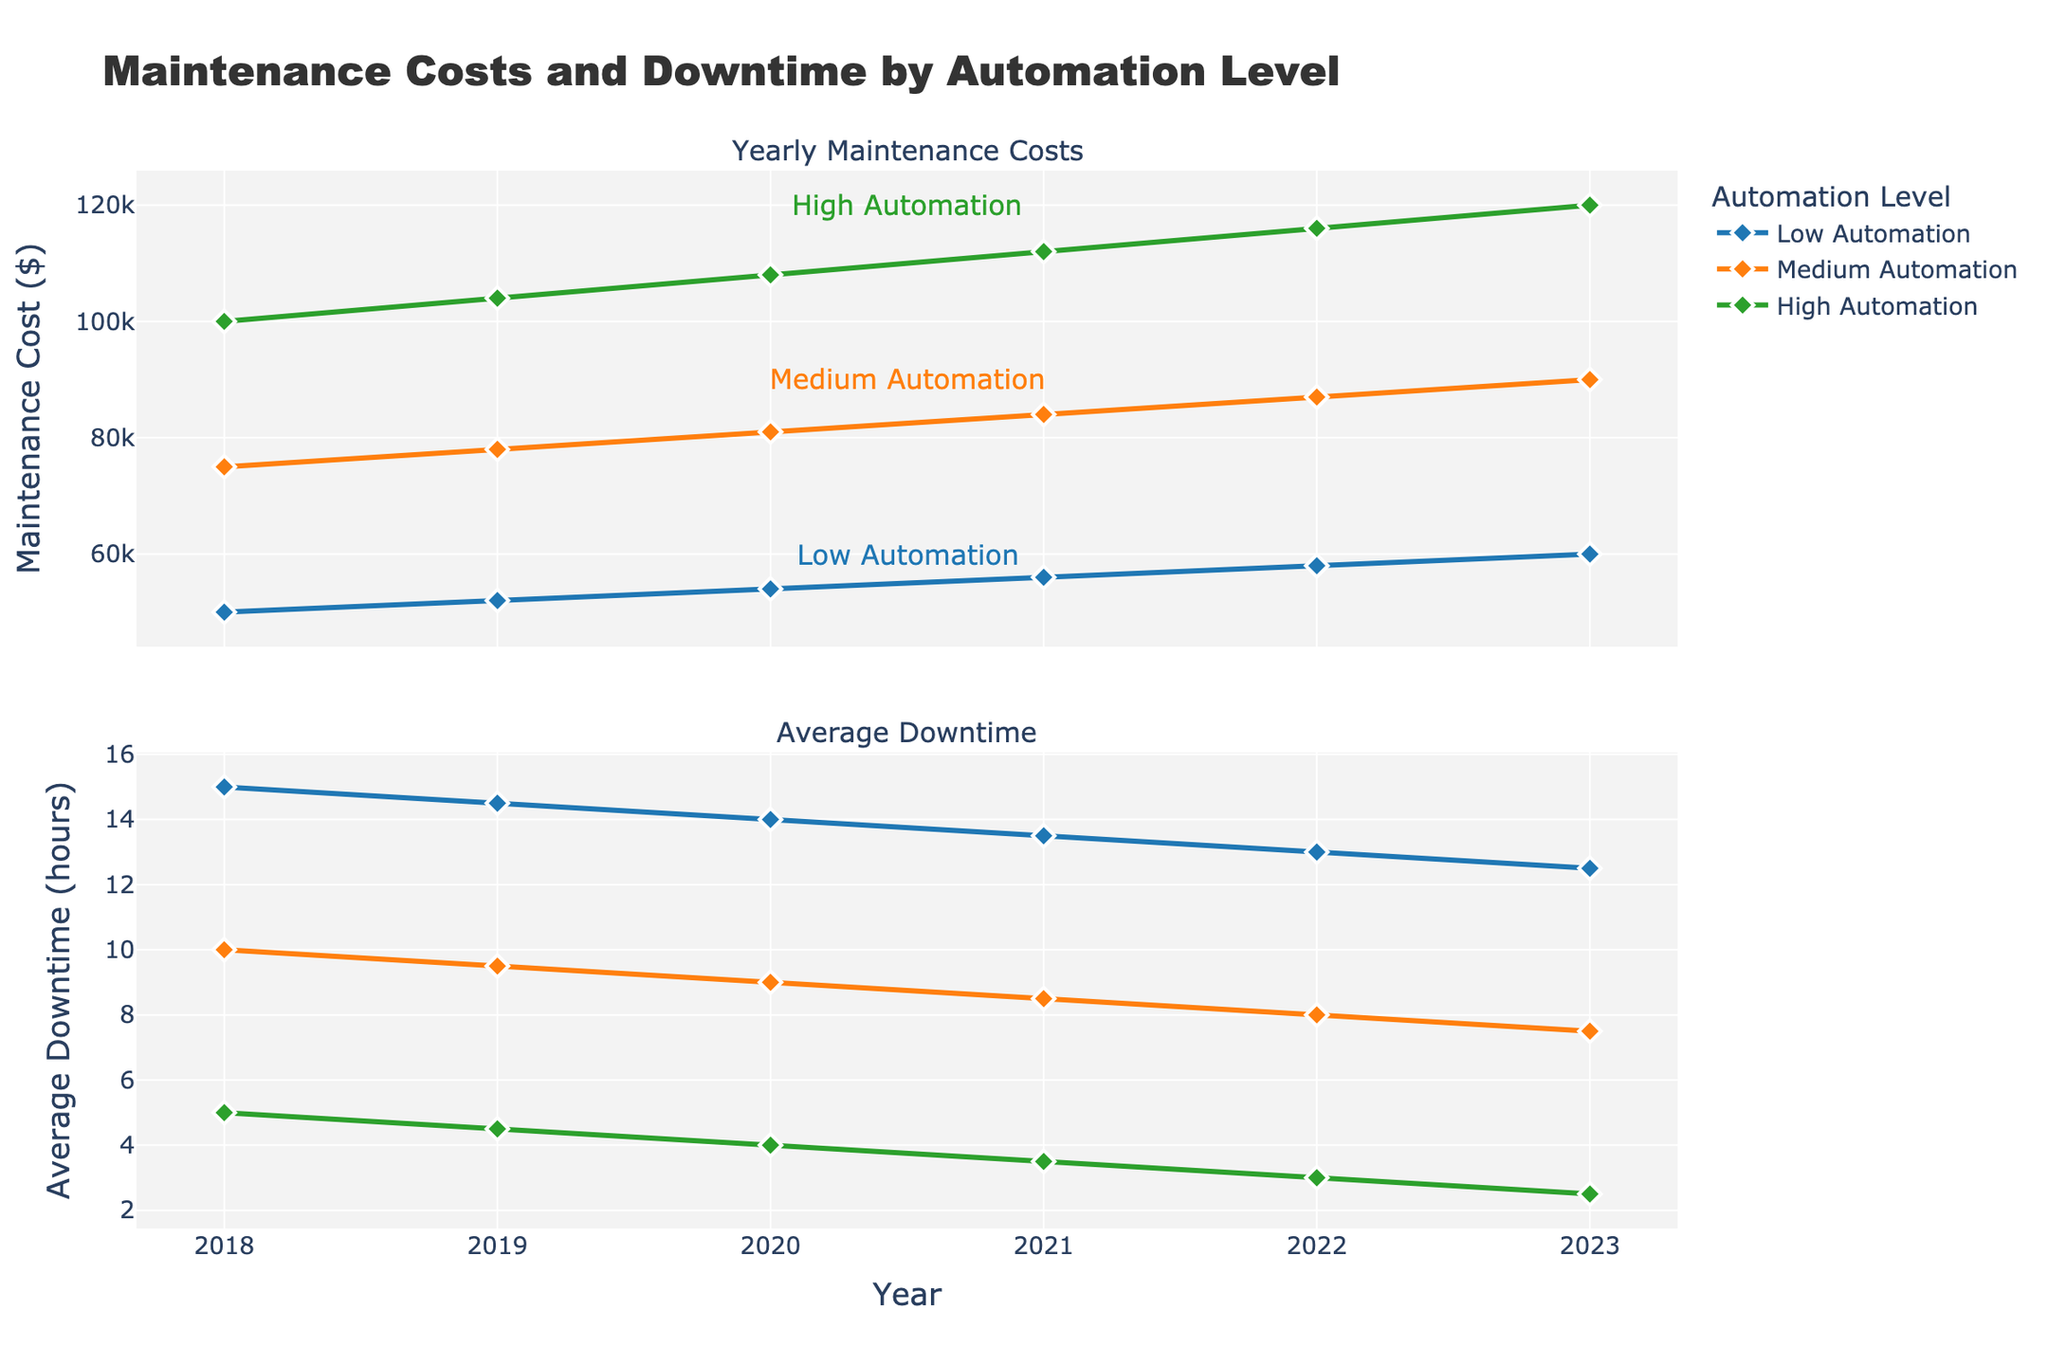What's the title of the figure? The title of the figure is written at the top center of the plot. It reads "Maintenance Costs and Downtime by Automation Level."
Answer: Maintenance Costs and Downtime by Automation Level Which automation level has the highest maintenance cost in 2023? To find the highest maintenance cost in 2023, look at the points for each automation level in the Yearly Maintenance Costs plot for the year 2023. The highest point in 2023 is for High Automation with a value of $120,000.
Answer: High Automation What is the average downtime for Low Automation in 2021? Average Downtime for Low Automation can be found in the Average Downtime plot at the point corresponding to 2021. The value at this point is 13.5 hours.
Answer: 13.5 hours How does average downtime change for Medium Automation from 2018 to 2023? To see how average downtime changes over this period for Medium Automation, follow the line and markers for Medium Automation in the Average Downtime plot from 2018 to 2023. In 2018, the downtime is 10 hours, and it decreases to 7.5 hours in 2023.
Answer: Decreases Compare the maintenance costs of Low and High Automation in 2020. Look at the Yearly Maintenance Costs plot for the year 2020. The maintenance cost for Low Automation is $54,000 and for High Automation is $108,000.
Answer: Low: $54,000, High: $108,000 What trend is observed in the maintenance costs for High Automation from 2018 to 2023? Observe the line for High Automation in the Yearly Maintenance Costs plot from 2018 to 2023. The maintenance costs increase steadily from $100,000 to $120,000 over these years.
Answer: Increasing What is the difference in average downtimes between Low and Medium Automation in 2023? Check the Average Downtime plot for the values of each automation level in 2023. Low Automation has a downtime of 12.5 hours, and Medium Automation has 7.5 hours. The difference is 12.5 - 7.5 = 5 hours.
Answer: 5 hours What color represents Low Automation in the plots? Find the color used for Low Automation lines and markers in both subplots. The color is a shade of blue.
Answer: Blue Which automation level shows the least average downtime consistently over the years? Look at both the lines and markers in the Average Downtime plot for all years. The High Automation level consistently shows the least average downtime when compared to Low and Medium Automation levels.
Answer: High Automation Which plot shows a sharper declining trend over the years, Maintenance Costs or Average Downtime for Low Automation? For Low Automation, compare the trends in both plots. In the Maintenance Costs plot, costs increase slightly each year. In the Average Downtime plot, downtime decreases from 15 hours in 2018 to 12.5 hours in 2023. The Average Downtime plot shows a sharper declining trend.
Answer: Average Downtime 